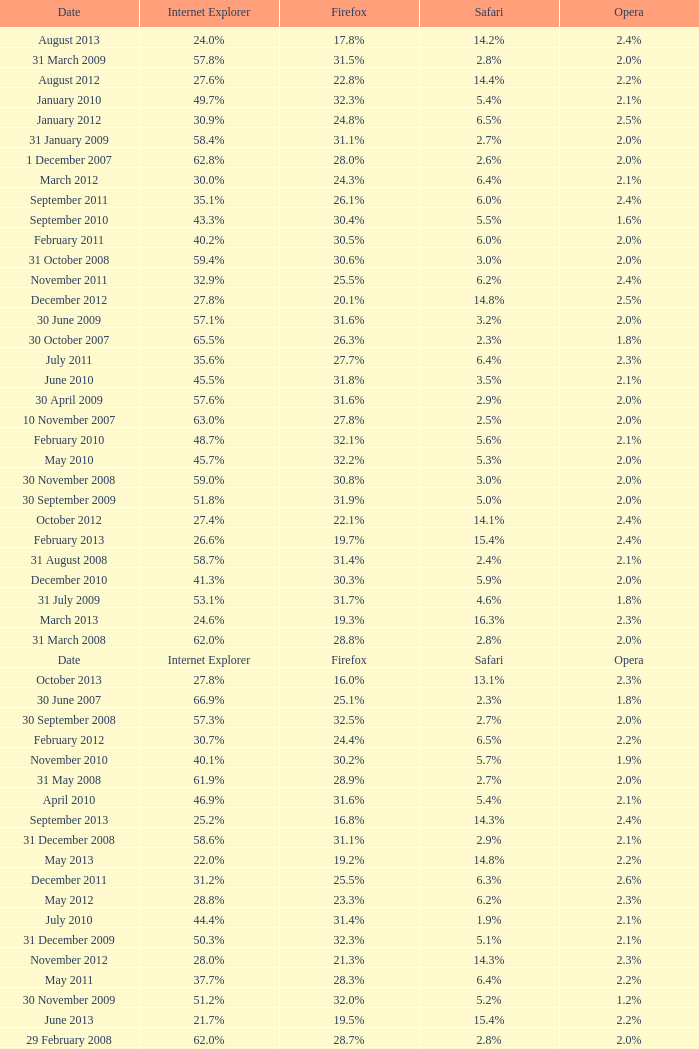What is the firefox value with a 22.0% internet explorer? 19.2%. 